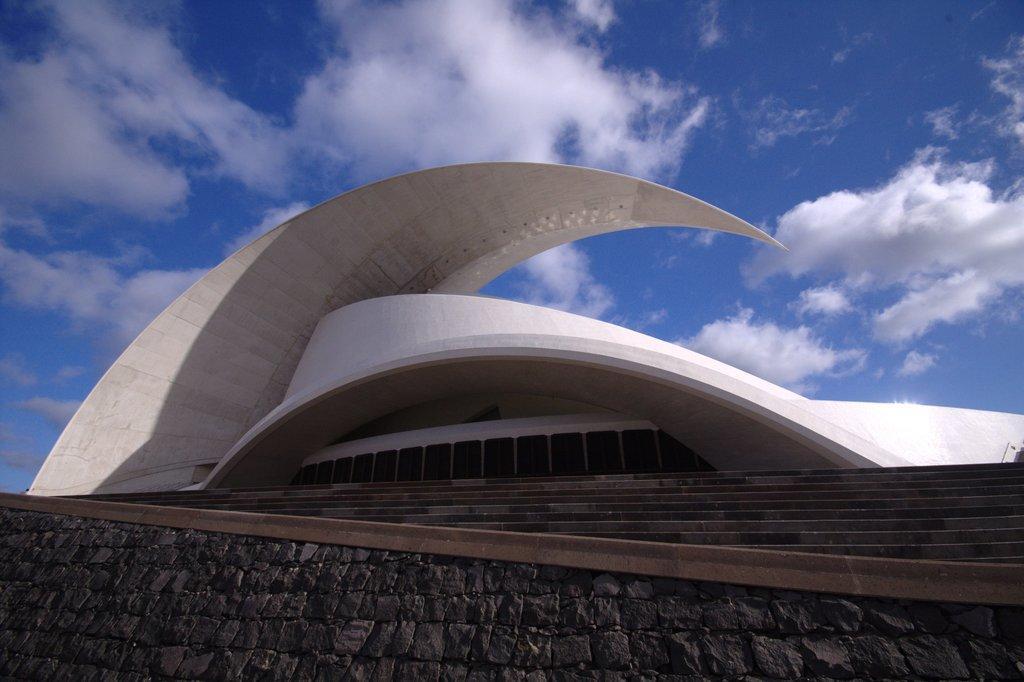Can you describe this image briefly? In the picture I can see a white color building and steps. In the background I can see the sky. 